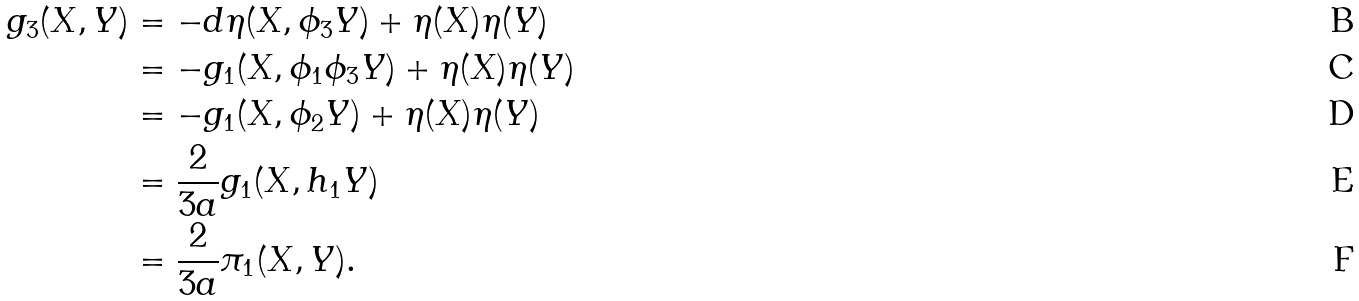<formula> <loc_0><loc_0><loc_500><loc_500>g _ { 3 } ( X , Y ) & = - d \eta ( X , \phi _ { 3 } Y ) + \eta ( X ) \eta ( Y ) \\ & = - g _ { 1 } ( X , \phi _ { 1 } \phi _ { 3 } Y ) + \eta ( X ) \eta ( Y ) \\ & = - g _ { 1 } ( X , \phi _ { 2 } Y ) + \eta ( X ) \eta ( Y ) \\ & = \frac { 2 } { 3 a } g _ { 1 } ( X , h _ { 1 } Y ) \\ & = \frac { 2 } { 3 a } \pi _ { 1 } ( X , Y ) .</formula> 